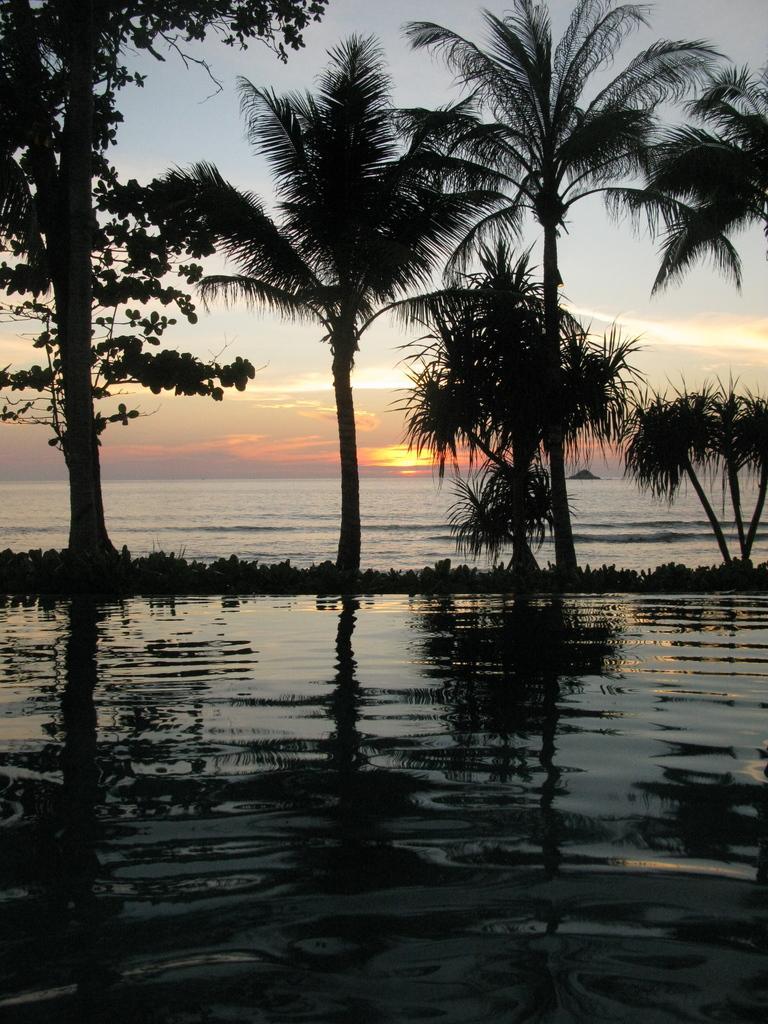How would you summarize this image in a sentence or two? In this image in front there is water. There are plants, trees. In the background of the image there is sun and there is sky. 